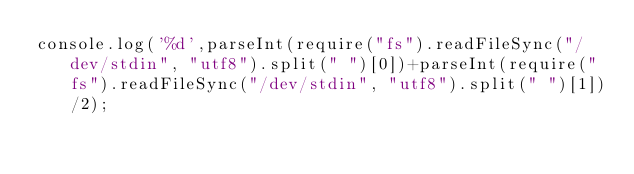<code> <loc_0><loc_0><loc_500><loc_500><_JavaScript_>console.log('%d',parseInt(require("fs").readFileSync("/dev/stdin", "utf8").split(" ")[0])+parseInt(require("fs").readFileSync("/dev/stdin", "utf8").split(" ")[1])/2);</code> 